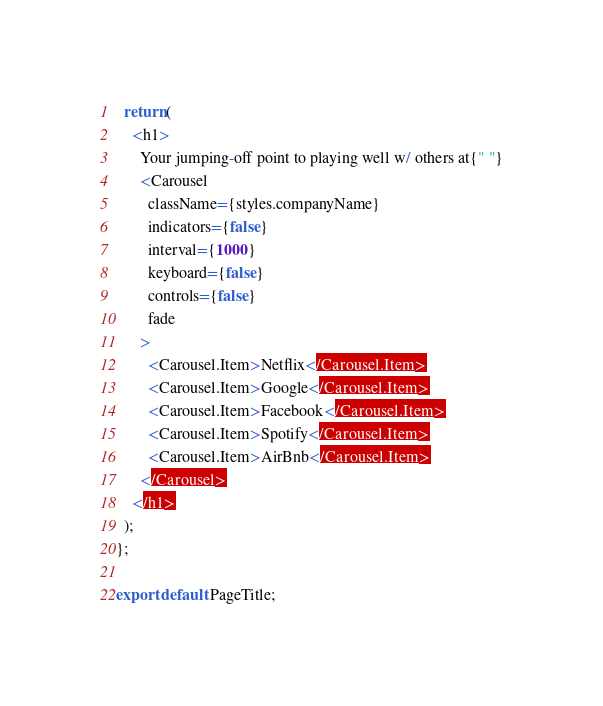Convert code to text. <code><loc_0><loc_0><loc_500><loc_500><_TypeScript_>  return (
    <h1>
      Your jumping-off point to playing well w/ others at{" "}
      <Carousel
        className={styles.companyName}
        indicators={false}
        interval={1000}
        keyboard={false}
        controls={false}
        fade
      >
        <Carousel.Item>Netflix</Carousel.Item>
        <Carousel.Item>Google</Carousel.Item>
        <Carousel.Item>Facebook</Carousel.Item>
        <Carousel.Item>Spotify</Carousel.Item>
        <Carousel.Item>AirBnb</Carousel.Item>
      </Carousel>
    </h1>
  );
};

export default PageTitle;
</code> 